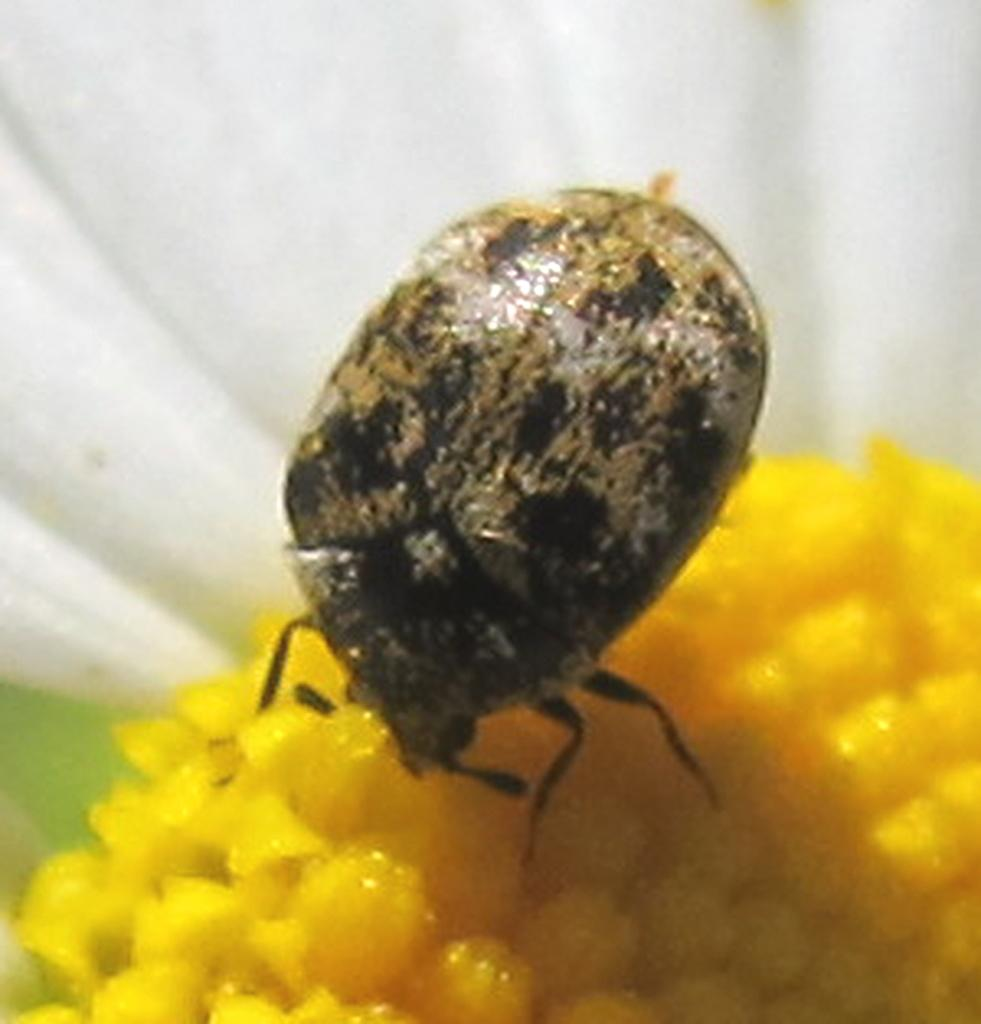What insect is present in the image? There is a leaf beetle in the image. What is the leaf beetle resting on? The leaf beetle is on a flower. What color is the flower? The flower is yellow in color. What color is the background of the image? The background of the image is white. What type of caption is written on the image? There is no caption present in the image. Can you describe the fight between the tiger and the leaf beetle in the image? There is no tiger present in the image, and the leaf beetle is not engaged in a fight. 